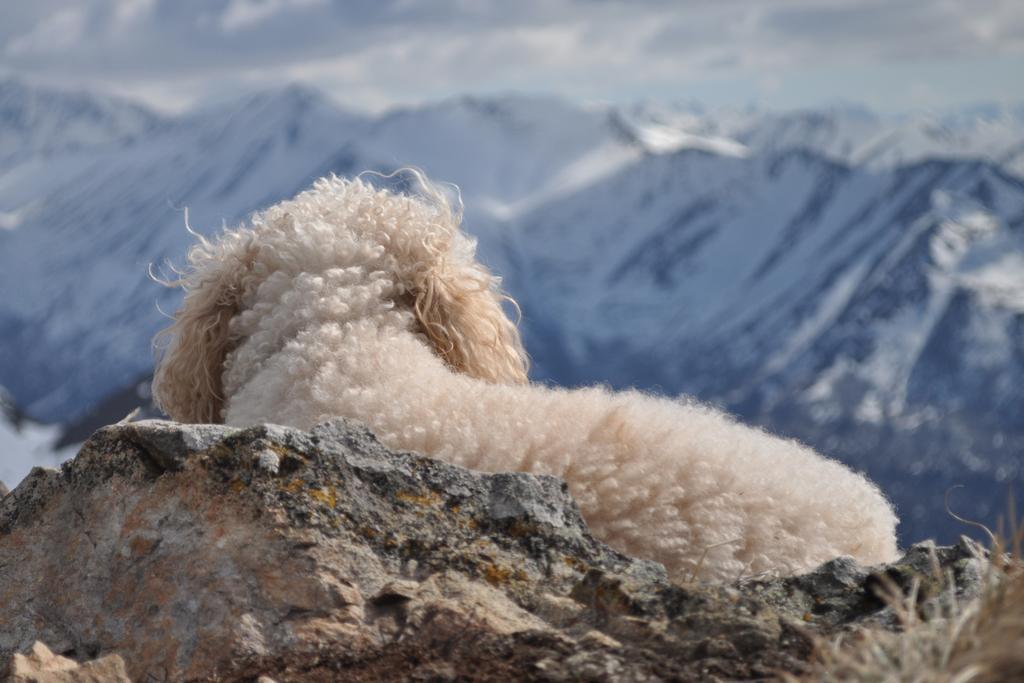Please provide a concise description of this image. In the center of the image there is an animal. At the bottom there is a rock. In the background there are mountains. 